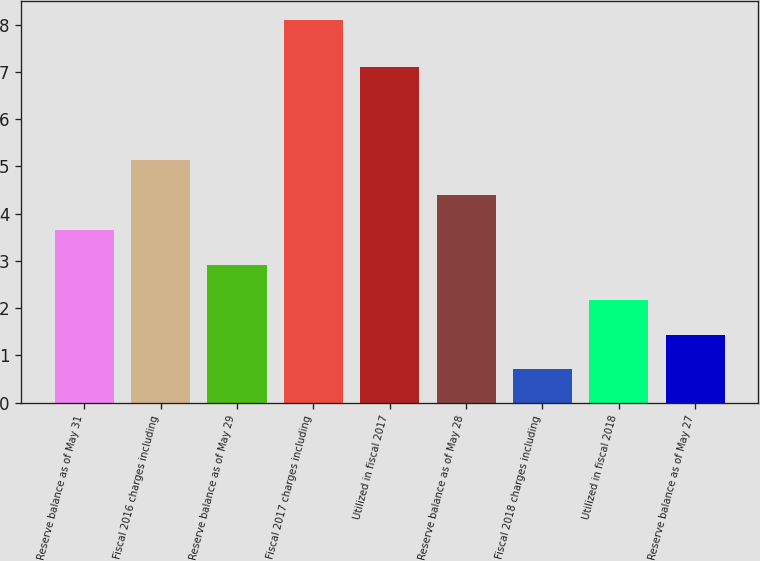Convert chart. <chart><loc_0><loc_0><loc_500><loc_500><bar_chart><fcel>Reserve balance as of May 31<fcel>Fiscal 2016 charges including<fcel>Reserve balance as of May 29<fcel>Fiscal 2017 charges including<fcel>Utilized in fiscal 2017<fcel>Reserve balance as of May 28<fcel>Fiscal 2018 charges including<fcel>Utilized in fiscal 2018<fcel>Reserve balance as of May 27<nl><fcel>3.66<fcel>5.14<fcel>2.92<fcel>8.1<fcel>7.1<fcel>4.4<fcel>0.7<fcel>2.18<fcel>1.44<nl></chart> 